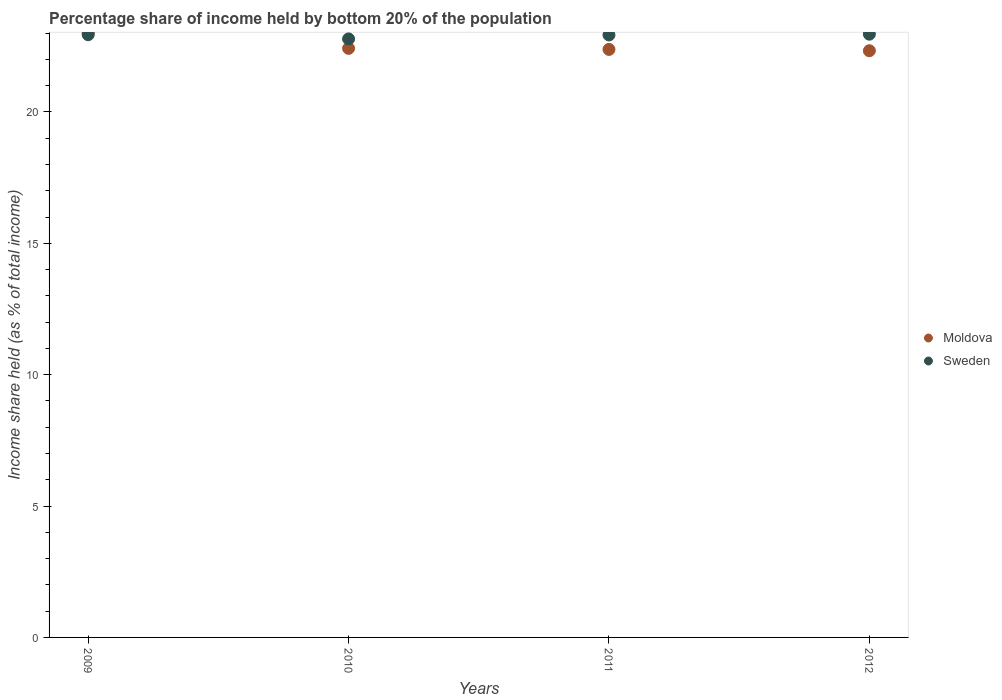How many different coloured dotlines are there?
Offer a terse response. 2. What is the share of income held by bottom 20% of the population in Moldova in 2010?
Ensure brevity in your answer.  22.42. Across all years, what is the maximum share of income held by bottom 20% of the population in Sweden?
Your response must be concise. 22.96. Across all years, what is the minimum share of income held by bottom 20% of the population in Moldova?
Offer a terse response. 22.33. In which year was the share of income held by bottom 20% of the population in Moldova maximum?
Make the answer very short. 2009. In which year was the share of income held by bottom 20% of the population in Moldova minimum?
Offer a very short reply. 2012. What is the total share of income held by bottom 20% of the population in Sweden in the graph?
Your answer should be very brief. 91.61. What is the difference between the share of income held by bottom 20% of the population in Sweden in 2009 and that in 2011?
Your answer should be compact. 0.01. What is the difference between the share of income held by bottom 20% of the population in Sweden in 2009 and the share of income held by bottom 20% of the population in Moldova in 2012?
Provide a succinct answer. 0.61. What is the average share of income held by bottom 20% of the population in Sweden per year?
Keep it short and to the point. 22.9. In the year 2010, what is the difference between the share of income held by bottom 20% of the population in Moldova and share of income held by bottom 20% of the population in Sweden?
Ensure brevity in your answer.  -0.36. What is the ratio of the share of income held by bottom 20% of the population in Moldova in 2010 to that in 2012?
Offer a terse response. 1. Is the share of income held by bottom 20% of the population in Sweden in 2009 less than that in 2011?
Your answer should be compact. No. What is the difference between the highest and the second highest share of income held by bottom 20% of the population in Sweden?
Provide a succinct answer. 0.02. What is the difference between the highest and the lowest share of income held by bottom 20% of the population in Moldova?
Keep it short and to the point. 0.67. In how many years, is the share of income held by bottom 20% of the population in Sweden greater than the average share of income held by bottom 20% of the population in Sweden taken over all years?
Your response must be concise. 3. Is the sum of the share of income held by bottom 20% of the population in Sweden in 2009 and 2012 greater than the maximum share of income held by bottom 20% of the population in Moldova across all years?
Offer a very short reply. Yes. Does the share of income held by bottom 20% of the population in Sweden monotonically increase over the years?
Your answer should be compact. No. Is the share of income held by bottom 20% of the population in Sweden strictly greater than the share of income held by bottom 20% of the population in Moldova over the years?
Provide a short and direct response. No. How many dotlines are there?
Your answer should be compact. 2. Does the graph contain any zero values?
Your response must be concise. No. Where does the legend appear in the graph?
Your answer should be very brief. Center right. How many legend labels are there?
Ensure brevity in your answer.  2. How are the legend labels stacked?
Give a very brief answer. Vertical. What is the title of the graph?
Provide a short and direct response. Percentage share of income held by bottom 20% of the population. What is the label or title of the X-axis?
Your answer should be compact. Years. What is the label or title of the Y-axis?
Keep it short and to the point. Income share held (as % of total income). What is the Income share held (as % of total income) in Sweden in 2009?
Your answer should be very brief. 22.94. What is the Income share held (as % of total income) in Moldova in 2010?
Your response must be concise. 22.42. What is the Income share held (as % of total income) in Sweden in 2010?
Offer a very short reply. 22.78. What is the Income share held (as % of total income) in Moldova in 2011?
Keep it short and to the point. 22.38. What is the Income share held (as % of total income) in Sweden in 2011?
Keep it short and to the point. 22.93. What is the Income share held (as % of total income) in Moldova in 2012?
Give a very brief answer. 22.33. What is the Income share held (as % of total income) of Sweden in 2012?
Your response must be concise. 22.96. Across all years, what is the maximum Income share held (as % of total income) of Sweden?
Your answer should be very brief. 22.96. Across all years, what is the minimum Income share held (as % of total income) of Moldova?
Provide a succinct answer. 22.33. Across all years, what is the minimum Income share held (as % of total income) in Sweden?
Your answer should be very brief. 22.78. What is the total Income share held (as % of total income) of Moldova in the graph?
Offer a very short reply. 90.13. What is the total Income share held (as % of total income) of Sweden in the graph?
Offer a very short reply. 91.61. What is the difference between the Income share held (as % of total income) in Moldova in 2009 and that in 2010?
Your response must be concise. 0.58. What is the difference between the Income share held (as % of total income) of Sweden in 2009 and that in 2010?
Give a very brief answer. 0.16. What is the difference between the Income share held (as % of total income) of Moldova in 2009 and that in 2011?
Provide a succinct answer. 0.62. What is the difference between the Income share held (as % of total income) of Moldova in 2009 and that in 2012?
Your answer should be compact. 0.67. What is the difference between the Income share held (as % of total income) in Sweden in 2009 and that in 2012?
Your response must be concise. -0.02. What is the difference between the Income share held (as % of total income) of Moldova in 2010 and that in 2011?
Give a very brief answer. 0.04. What is the difference between the Income share held (as % of total income) of Sweden in 2010 and that in 2011?
Keep it short and to the point. -0.15. What is the difference between the Income share held (as % of total income) in Moldova in 2010 and that in 2012?
Offer a very short reply. 0.09. What is the difference between the Income share held (as % of total income) of Sweden in 2010 and that in 2012?
Your response must be concise. -0.18. What is the difference between the Income share held (as % of total income) in Moldova in 2011 and that in 2012?
Provide a succinct answer. 0.05. What is the difference between the Income share held (as % of total income) in Sweden in 2011 and that in 2012?
Provide a short and direct response. -0.03. What is the difference between the Income share held (as % of total income) of Moldova in 2009 and the Income share held (as % of total income) of Sweden in 2010?
Keep it short and to the point. 0.22. What is the difference between the Income share held (as % of total income) of Moldova in 2009 and the Income share held (as % of total income) of Sweden in 2011?
Ensure brevity in your answer.  0.07. What is the difference between the Income share held (as % of total income) in Moldova in 2010 and the Income share held (as % of total income) in Sweden in 2011?
Ensure brevity in your answer.  -0.51. What is the difference between the Income share held (as % of total income) of Moldova in 2010 and the Income share held (as % of total income) of Sweden in 2012?
Your answer should be compact. -0.54. What is the difference between the Income share held (as % of total income) of Moldova in 2011 and the Income share held (as % of total income) of Sweden in 2012?
Your answer should be compact. -0.58. What is the average Income share held (as % of total income) of Moldova per year?
Your answer should be compact. 22.53. What is the average Income share held (as % of total income) in Sweden per year?
Your response must be concise. 22.9. In the year 2009, what is the difference between the Income share held (as % of total income) of Moldova and Income share held (as % of total income) of Sweden?
Keep it short and to the point. 0.06. In the year 2010, what is the difference between the Income share held (as % of total income) in Moldova and Income share held (as % of total income) in Sweden?
Ensure brevity in your answer.  -0.36. In the year 2011, what is the difference between the Income share held (as % of total income) in Moldova and Income share held (as % of total income) in Sweden?
Your answer should be very brief. -0.55. In the year 2012, what is the difference between the Income share held (as % of total income) in Moldova and Income share held (as % of total income) in Sweden?
Make the answer very short. -0.63. What is the ratio of the Income share held (as % of total income) of Moldova in 2009 to that in 2010?
Offer a very short reply. 1.03. What is the ratio of the Income share held (as % of total income) of Moldova in 2009 to that in 2011?
Give a very brief answer. 1.03. What is the ratio of the Income share held (as % of total income) of Sweden in 2009 to that in 2012?
Make the answer very short. 1. What is the ratio of the Income share held (as % of total income) of Moldova in 2010 to that in 2012?
Your answer should be very brief. 1. What is the ratio of the Income share held (as % of total income) of Sweden in 2010 to that in 2012?
Make the answer very short. 0.99. What is the difference between the highest and the second highest Income share held (as % of total income) in Moldova?
Provide a succinct answer. 0.58. What is the difference between the highest and the second highest Income share held (as % of total income) in Sweden?
Offer a terse response. 0.02. What is the difference between the highest and the lowest Income share held (as % of total income) of Moldova?
Keep it short and to the point. 0.67. What is the difference between the highest and the lowest Income share held (as % of total income) of Sweden?
Keep it short and to the point. 0.18. 